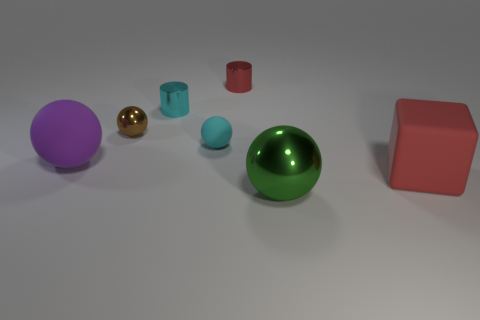Subtract 1 balls. How many balls are left? 3 Subtract all purple spheres. How many spheres are left? 3 Subtract all big rubber spheres. How many spheres are left? 3 Subtract all yellow spheres. Subtract all brown cylinders. How many spheres are left? 4 Add 2 large cyan objects. How many objects exist? 9 Subtract all cubes. How many objects are left? 6 Subtract all large brown metallic spheres. Subtract all big matte spheres. How many objects are left? 6 Add 6 large matte blocks. How many large matte blocks are left? 7 Add 3 big purple objects. How many big purple objects exist? 4 Subtract 0 blue cylinders. How many objects are left? 7 